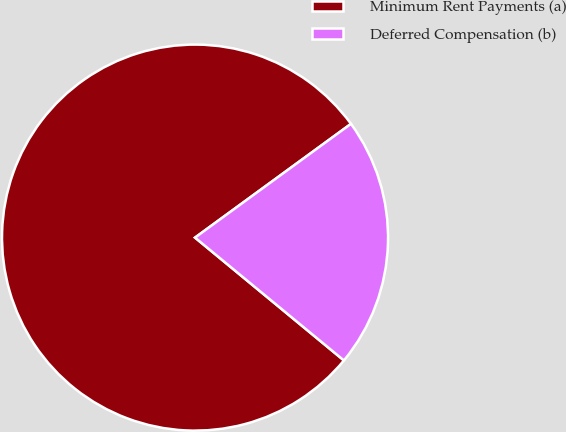Convert chart to OTSL. <chart><loc_0><loc_0><loc_500><loc_500><pie_chart><fcel>Minimum Rent Payments (a)<fcel>Deferred Compensation (b)<nl><fcel>78.99%<fcel>21.01%<nl></chart> 